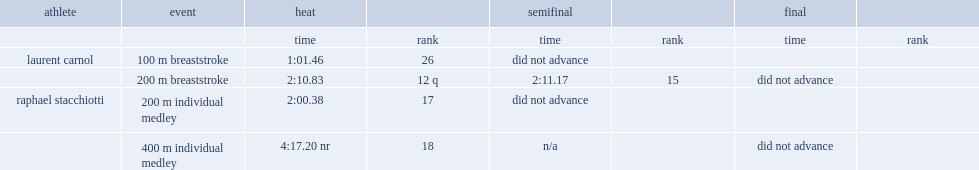I'm looking to parse the entire table for insights. Could you assist me with that? {'header': ['athlete', 'event', 'heat', '', 'semifinal', '', 'final', ''], 'rows': [['', '', 'time', 'rank', 'time', 'rank', 'time', 'rank'], ['laurent carnol', '100 m breaststroke', '1:01.46', '26', 'did not advance', '', '', ''], ['', '200 m breaststroke', '2:10.83', '12 q', '2:11.17', '15', 'did not advance', ''], ['raphael stacchiotti', '200 m individual medley', '2:00.38', '17', 'did not advance', '', '', ''], ['', '400 m individual medley', '4:17.20 nr', '18', 'n/a', '', 'did not advance', '']]} What was the rank of laurent carnol in the semifinal in 200m event. 15.0. 